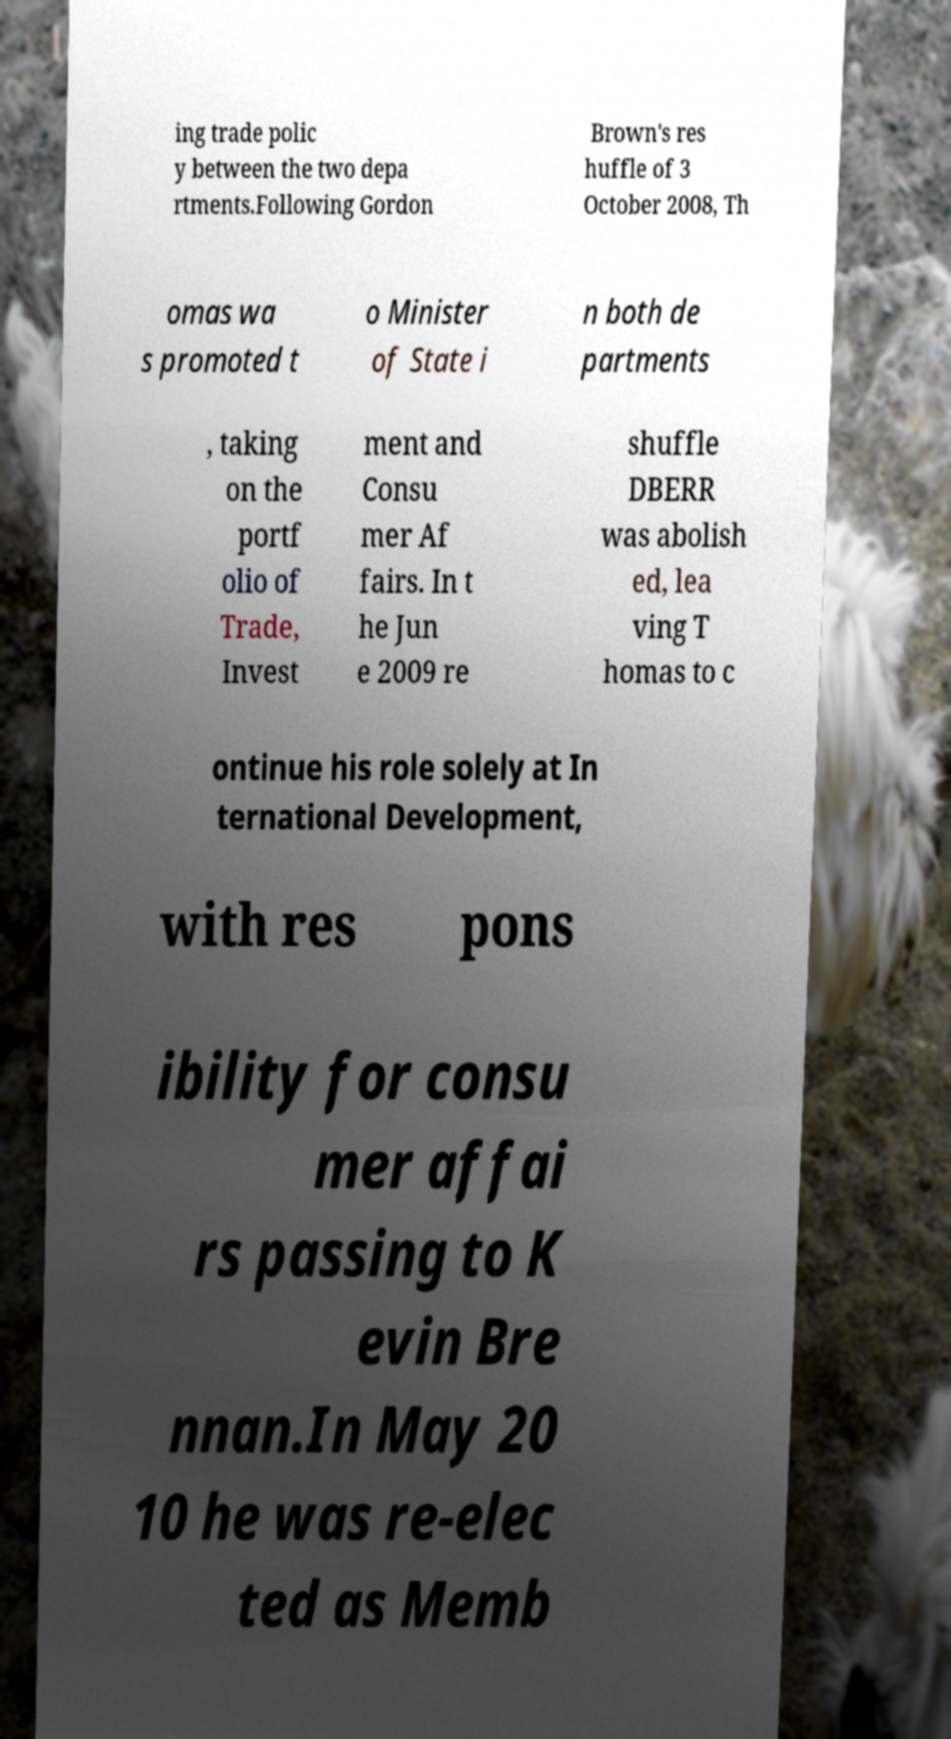Please identify and transcribe the text found in this image. ing trade polic y between the two depa rtments.Following Gordon Brown's res huffle of 3 October 2008, Th omas wa s promoted t o Minister of State i n both de partments , taking on the portf olio of Trade, Invest ment and Consu mer Af fairs. In t he Jun e 2009 re shuffle DBERR was abolish ed, lea ving T homas to c ontinue his role solely at In ternational Development, with res pons ibility for consu mer affai rs passing to K evin Bre nnan.In May 20 10 he was re-elec ted as Memb 